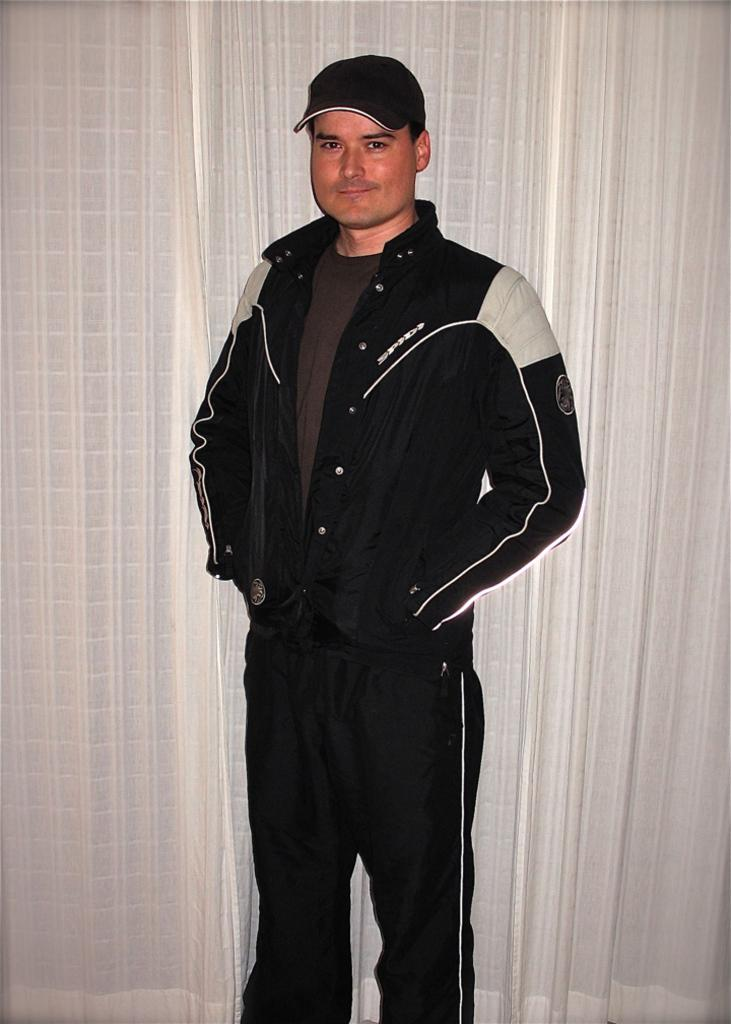What is the main subject of the image? There is a person standing in the image. What is the person wearing? The person is wearing a black dress and a black color cap. What can be seen in the background of the image? The background of the image includes white-colored curtains. Where is the lunchroom located in the image? There is no lunchroom present in the image. What type of line is visible in the image? There is no line visible in the image. 